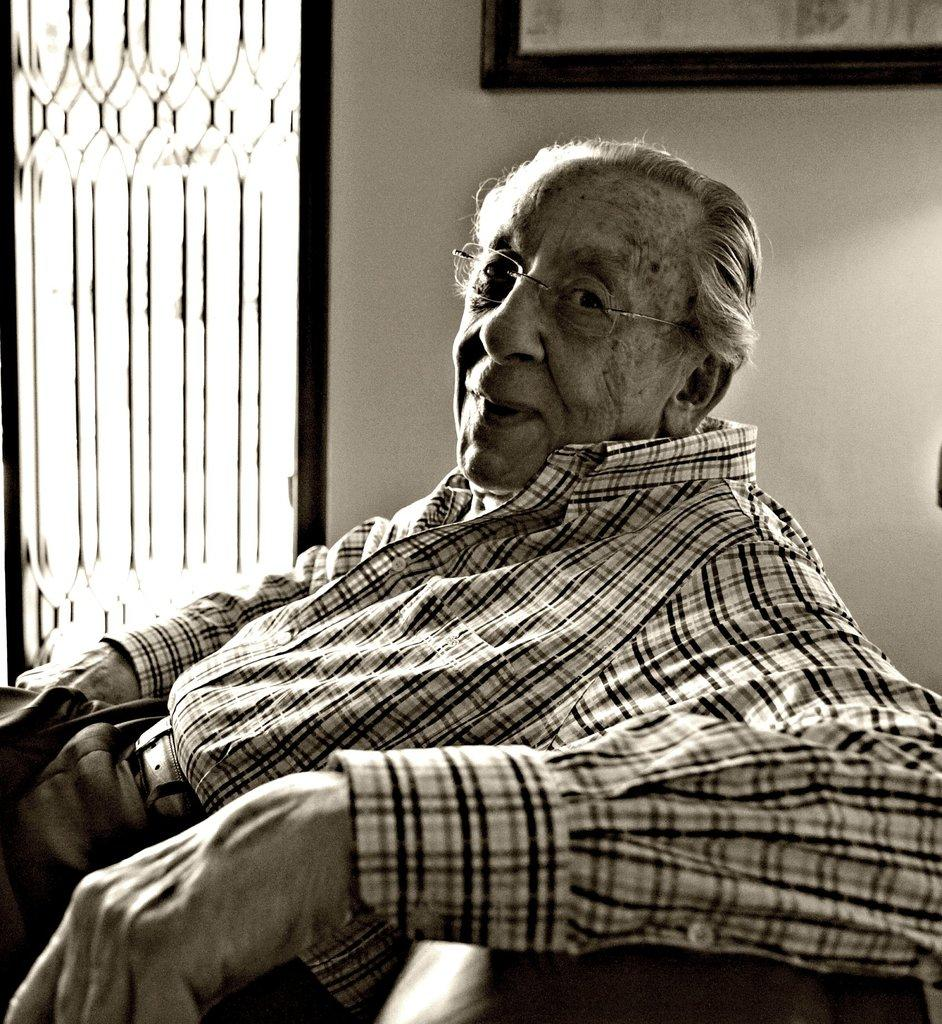What can be seen in the image? There is a person in the image. Can you describe the person's appearance? The person is wearing spectacles. What is the person doing in the image? The person is sitting. What is on the wall in the image? There is a wall with a frame in the image. What can be found on the left side of the image? There are objects on the left side of the image. Reasoning: Let' Let's think step by step in order to produce the conversation. We start by identifying the main subject in the image, which is the person. Then, we describe the person's appearance and actions. Next, we mention the wall with a frame and the objects on the left side of the image. Each question is designed to elicit a specific detail about the image that is known from the provided facts. Absurd Question/Answer: What type of curtain can be seen on the right side of the image? There is no curtain present on the right side of the image. How many girls are visible in the image? There is no mention of girls in the provided facts, so we cannot determine their presence in the image. What type of destruction can be seen in the image? There is no destruction present in the image. The provided facts only mention a person, spectacles, sitting, a wall with a frame, and objects on the left side of the image. 